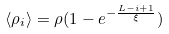Convert formula to latex. <formula><loc_0><loc_0><loc_500><loc_500>\langle \rho _ { i } \rangle = \rho ( 1 - e ^ { - \frac { L - i + 1 } { \xi } } )</formula> 